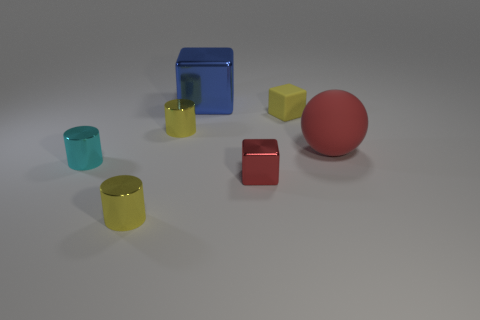Add 2 tiny cyan metallic cylinders. How many objects exist? 9 Subtract all balls. How many objects are left? 6 Subtract all tiny blue metallic cylinders. Subtract all tiny cyan cylinders. How many objects are left? 6 Add 6 blue blocks. How many blue blocks are left? 7 Add 1 small rubber spheres. How many small rubber spheres exist? 1 Subtract 0 yellow balls. How many objects are left? 7 